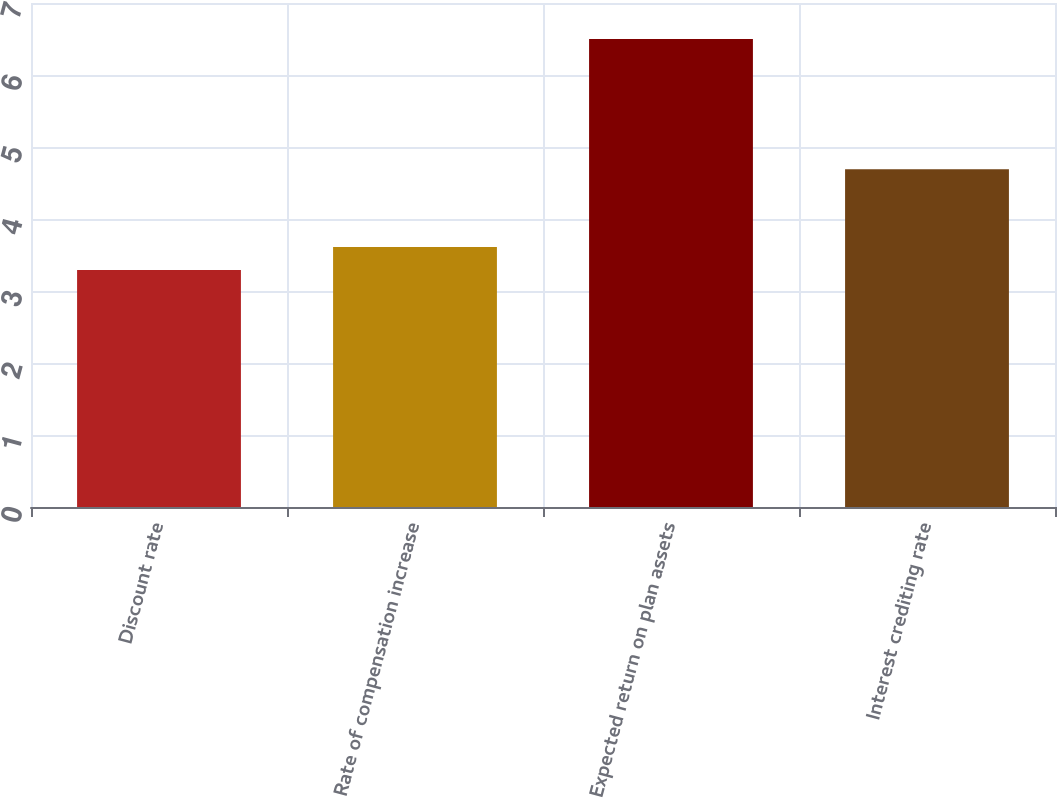<chart> <loc_0><loc_0><loc_500><loc_500><bar_chart><fcel>Discount rate<fcel>Rate of compensation increase<fcel>Expected return on plan assets<fcel>Interest crediting rate<nl><fcel>3.29<fcel>3.61<fcel>6.5<fcel>4.69<nl></chart> 